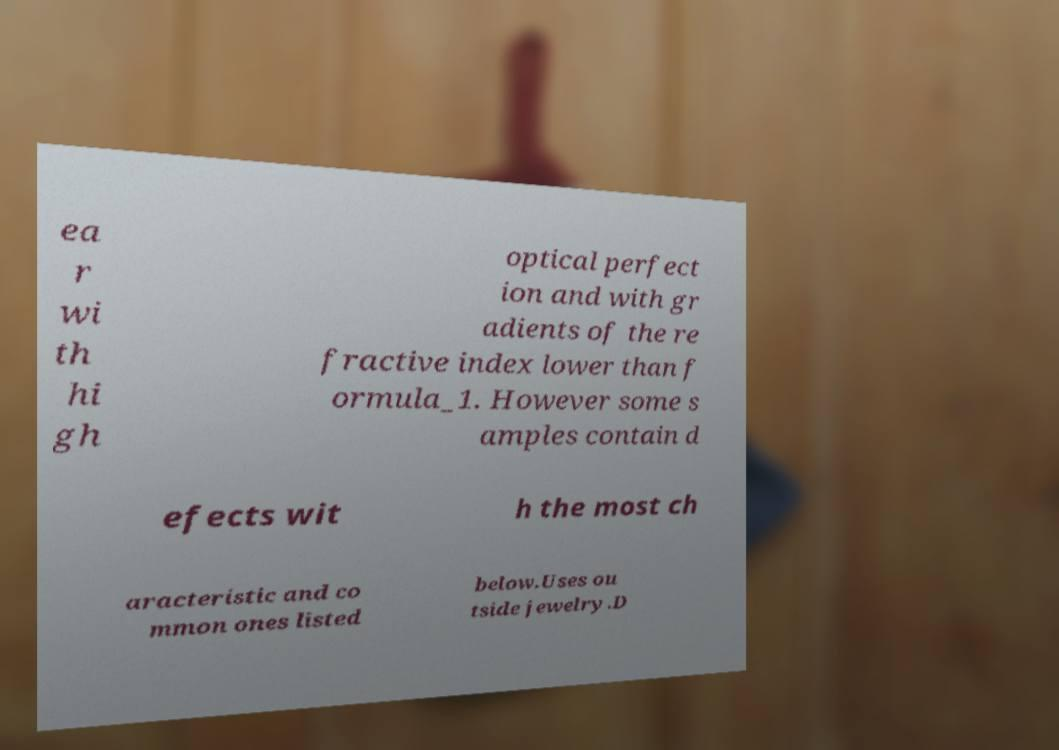What messages or text are displayed in this image? I need them in a readable, typed format. ea r wi th hi gh optical perfect ion and with gr adients of the re fractive index lower than f ormula_1. However some s amples contain d efects wit h the most ch aracteristic and co mmon ones listed below.Uses ou tside jewelry.D 